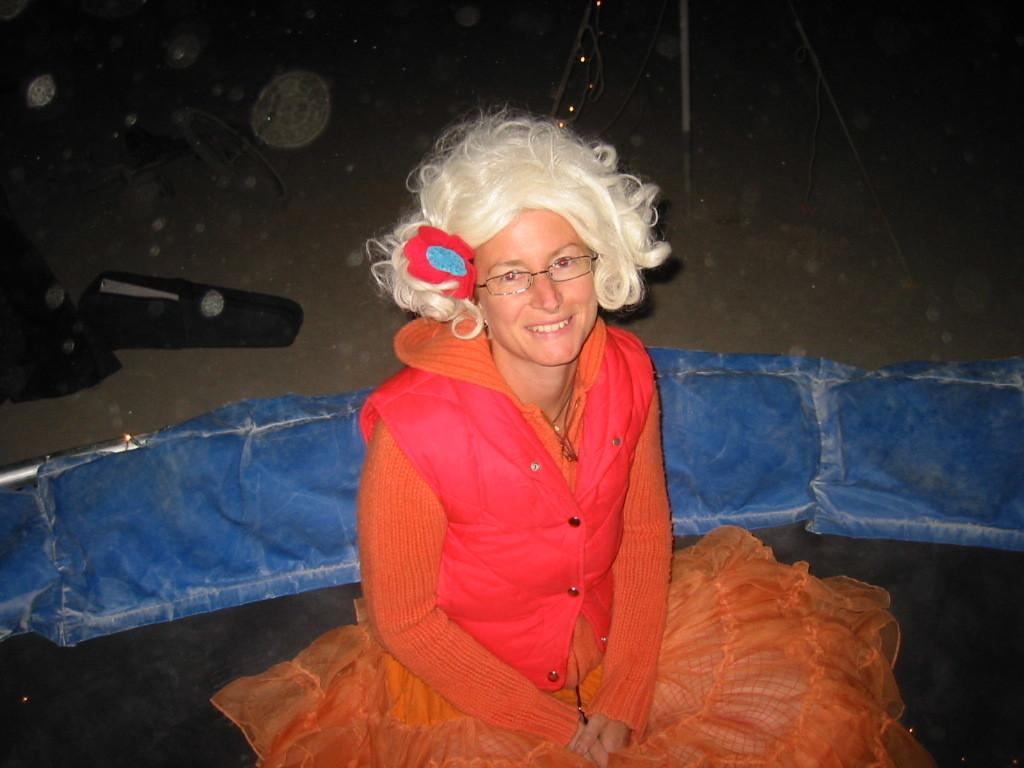Who is in the picture? There is a woman in the picture. What is the woman doing in the picture? The woman is sitting in the picture. What is the woman's facial expression in the picture? The woman is smiling in the picture. What can be seen on the ground in the picture? There are objects on the ground in the picture. What type of jam is being served on the stage in the picture? There is no jam or stage present in the picture; it features a woman sitting and smiling. 